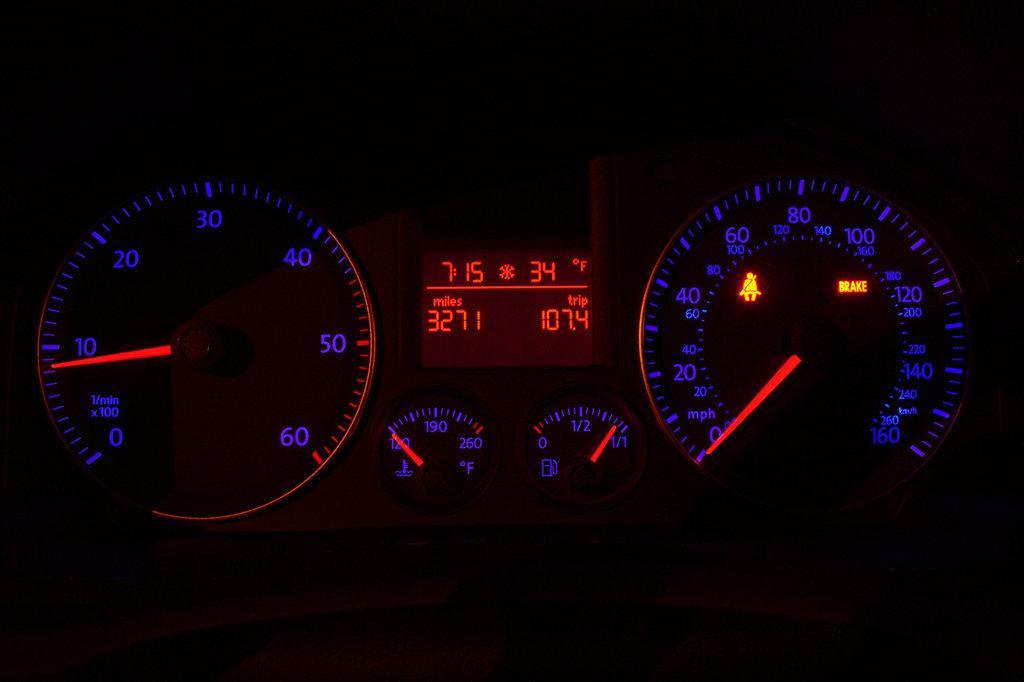Could you give a brief overview of what you see in this image? This image consists of speedometers. The background is in black color. 